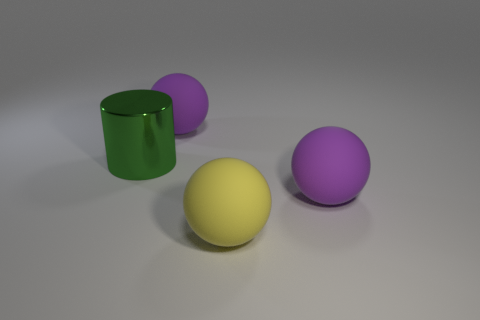Add 2 purple rubber balls. How many objects exist? 6 Subtract all spheres. How many objects are left? 1 Add 3 large cylinders. How many large cylinders exist? 4 Subtract 2 purple spheres. How many objects are left? 2 Subtract all small purple rubber balls. Subtract all large matte objects. How many objects are left? 1 Add 2 metallic things. How many metallic things are left? 3 